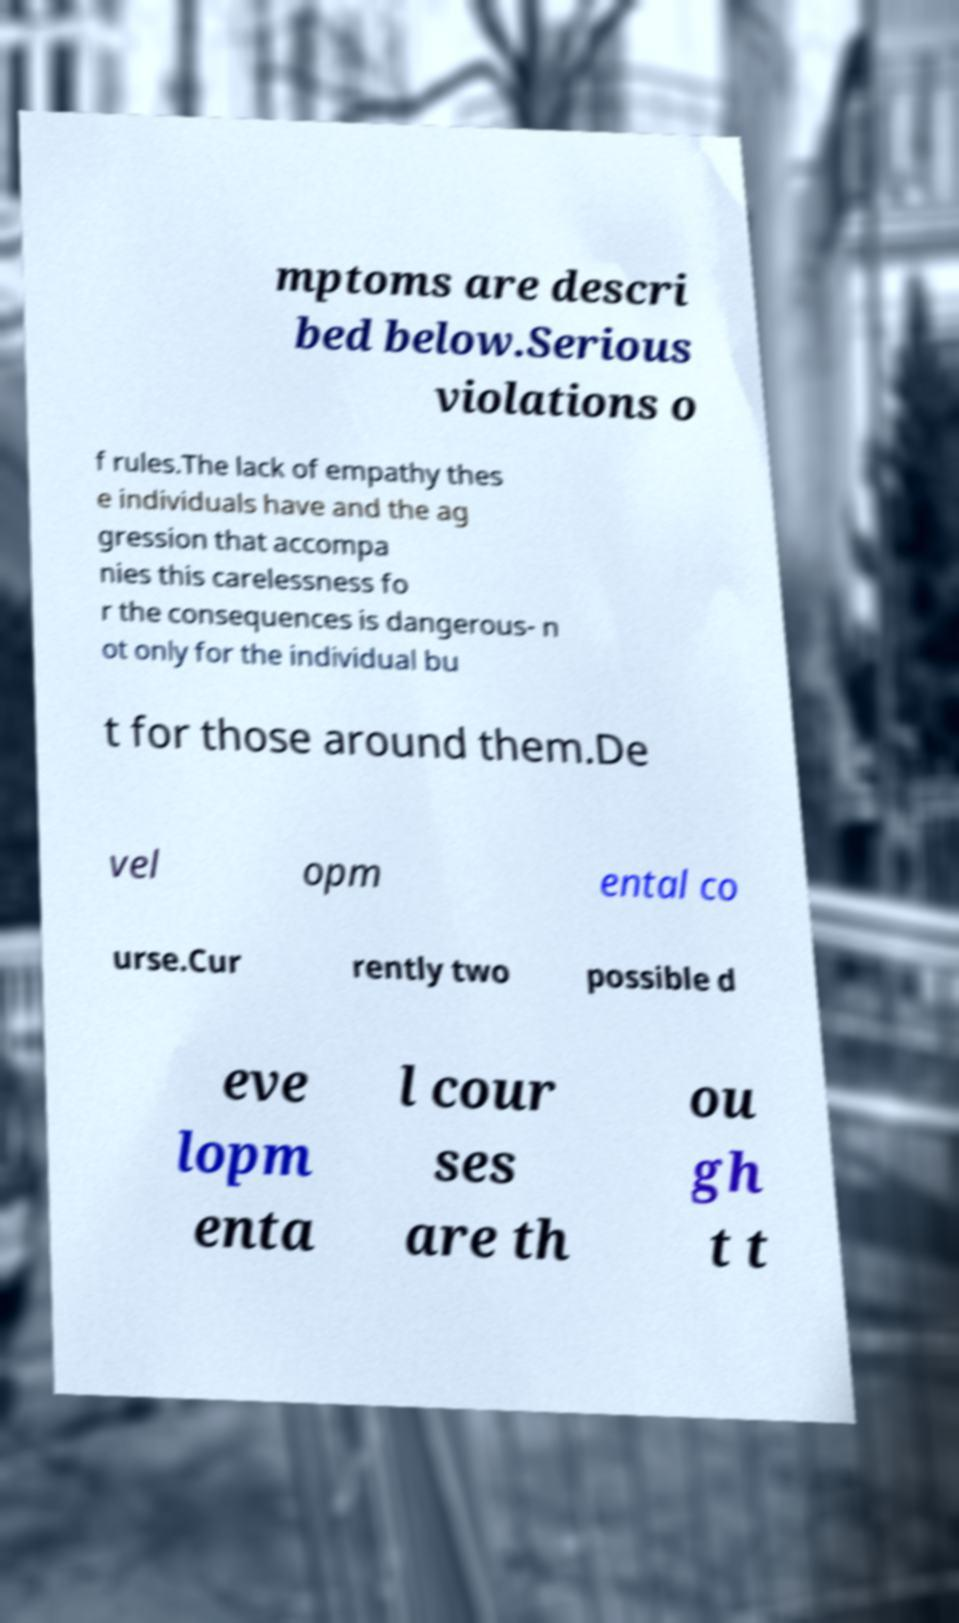For documentation purposes, I need the text within this image transcribed. Could you provide that? mptoms are descri bed below.Serious violations o f rules.The lack of empathy thes e individuals have and the ag gression that accompa nies this carelessness fo r the consequences is dangerous- n ot only for the individual bu t for those around them.De vel opm ental co urse.Cur rently two possible d eve lopm enta l cour ses are th ou gh t t 